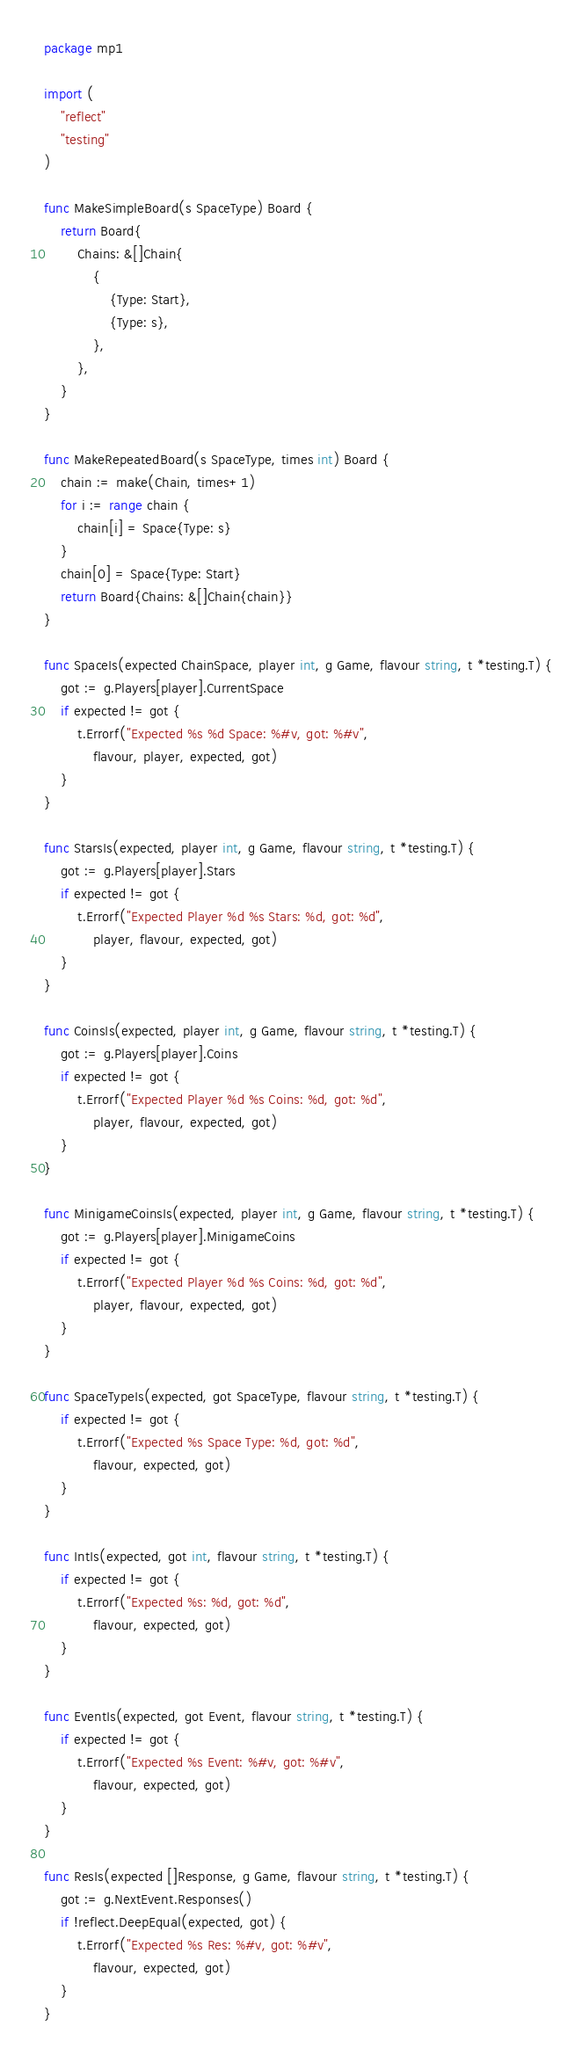<code> <loc_0><loc_0><loc_500><loc_500><_Go_>package mp1

import (
	"reflect"
	"testing"
)

func MakeSimpleBoard(s SpaceType) Board {
	return Board{
		Chains: &[]Chain{
			{
				{Type: Start},
				{Type: s},
			},
		},
	}
}

func MakeRepeatedBoard(s SpaceType, times int) Board {
	chain := make(Chain, times+1)
	for i := range chain {
		chain[i] = Space{Type: s}
	}
	chain[0] = Space{Type: Start}
	return Board{Chains: &[]Chain{chain}}
}

func SpaceIs(expected ChainSpace, player int, g Game, flavour string, t *testing.T) {
	got := g.Players[player].CurrentSpace
	if expected != got {
		t.Errorf("Expected %s %d Space: %#v, got: %#v",
			flavour, player, expected, got)
	}
}

func StarsIs(expected, player int, g Game, flavour string, t *testing.T) {
	got := g.Players[player].Stars
	if expected != got {
		t.Errorf("Expected Player %d %s Stars: %d, got: %d",
			player, flavour, expected, got)
	}
}

func CoinsIs(expected, player int, g Game, flavour string, t *testing.T) {
	got := g.Players[player].Coins
	if expected != got {
		t.Errorf("Expected Player %d %s Coins: %d, got: %d",
			player, flavour, expected, got)
	}
}

func MinigameCoinsIs(expected, player int, g Game, flavour string, t *testing.T) {
	got := g.Players[player].MinigameCoins
	if expected != got {
		t.Errorf("Expected Player %d %s Coins: %d, got: %d",
			player, flavour, expected, got)
	}
}

func SpaceTypeIs(expected, got SpaceType, flavour string, t *testing.T) {
	if expected != got {
		t.Errorf("Expected %s Space Type: %d, got: %d",
			flavour, expected, got)
	}
}

func IntIs(expected, got int, flavour string, t *testing.T) {
	if expected != got {
		t.Errorf("Expected %s: %d, got: %d",
			flavour, expected, got)
	}
}

func EventIs(expected, got Event, flavour string, t *testing.T) {
	if expected != got {
		t.Errorf("Expected %s Event: %#v, got: %#v",
			flavour, expected, got)
	}
}

func ResIs(expected []Response, g Game, flavour string, t *testing.T) {
	got := g.NextEvent.Responses()
	if !reflect.DeepEqual(expected, got) {
		t.Errorf("Expected %s Res: %#v, got: %#v",
			flavour, expected, got)
	}
}
</code> 